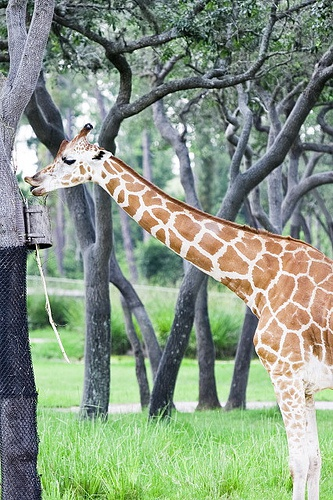Describe the objects in this image and their specific colors. I can see a giraffe in teal, white, and tan tones in this image. 